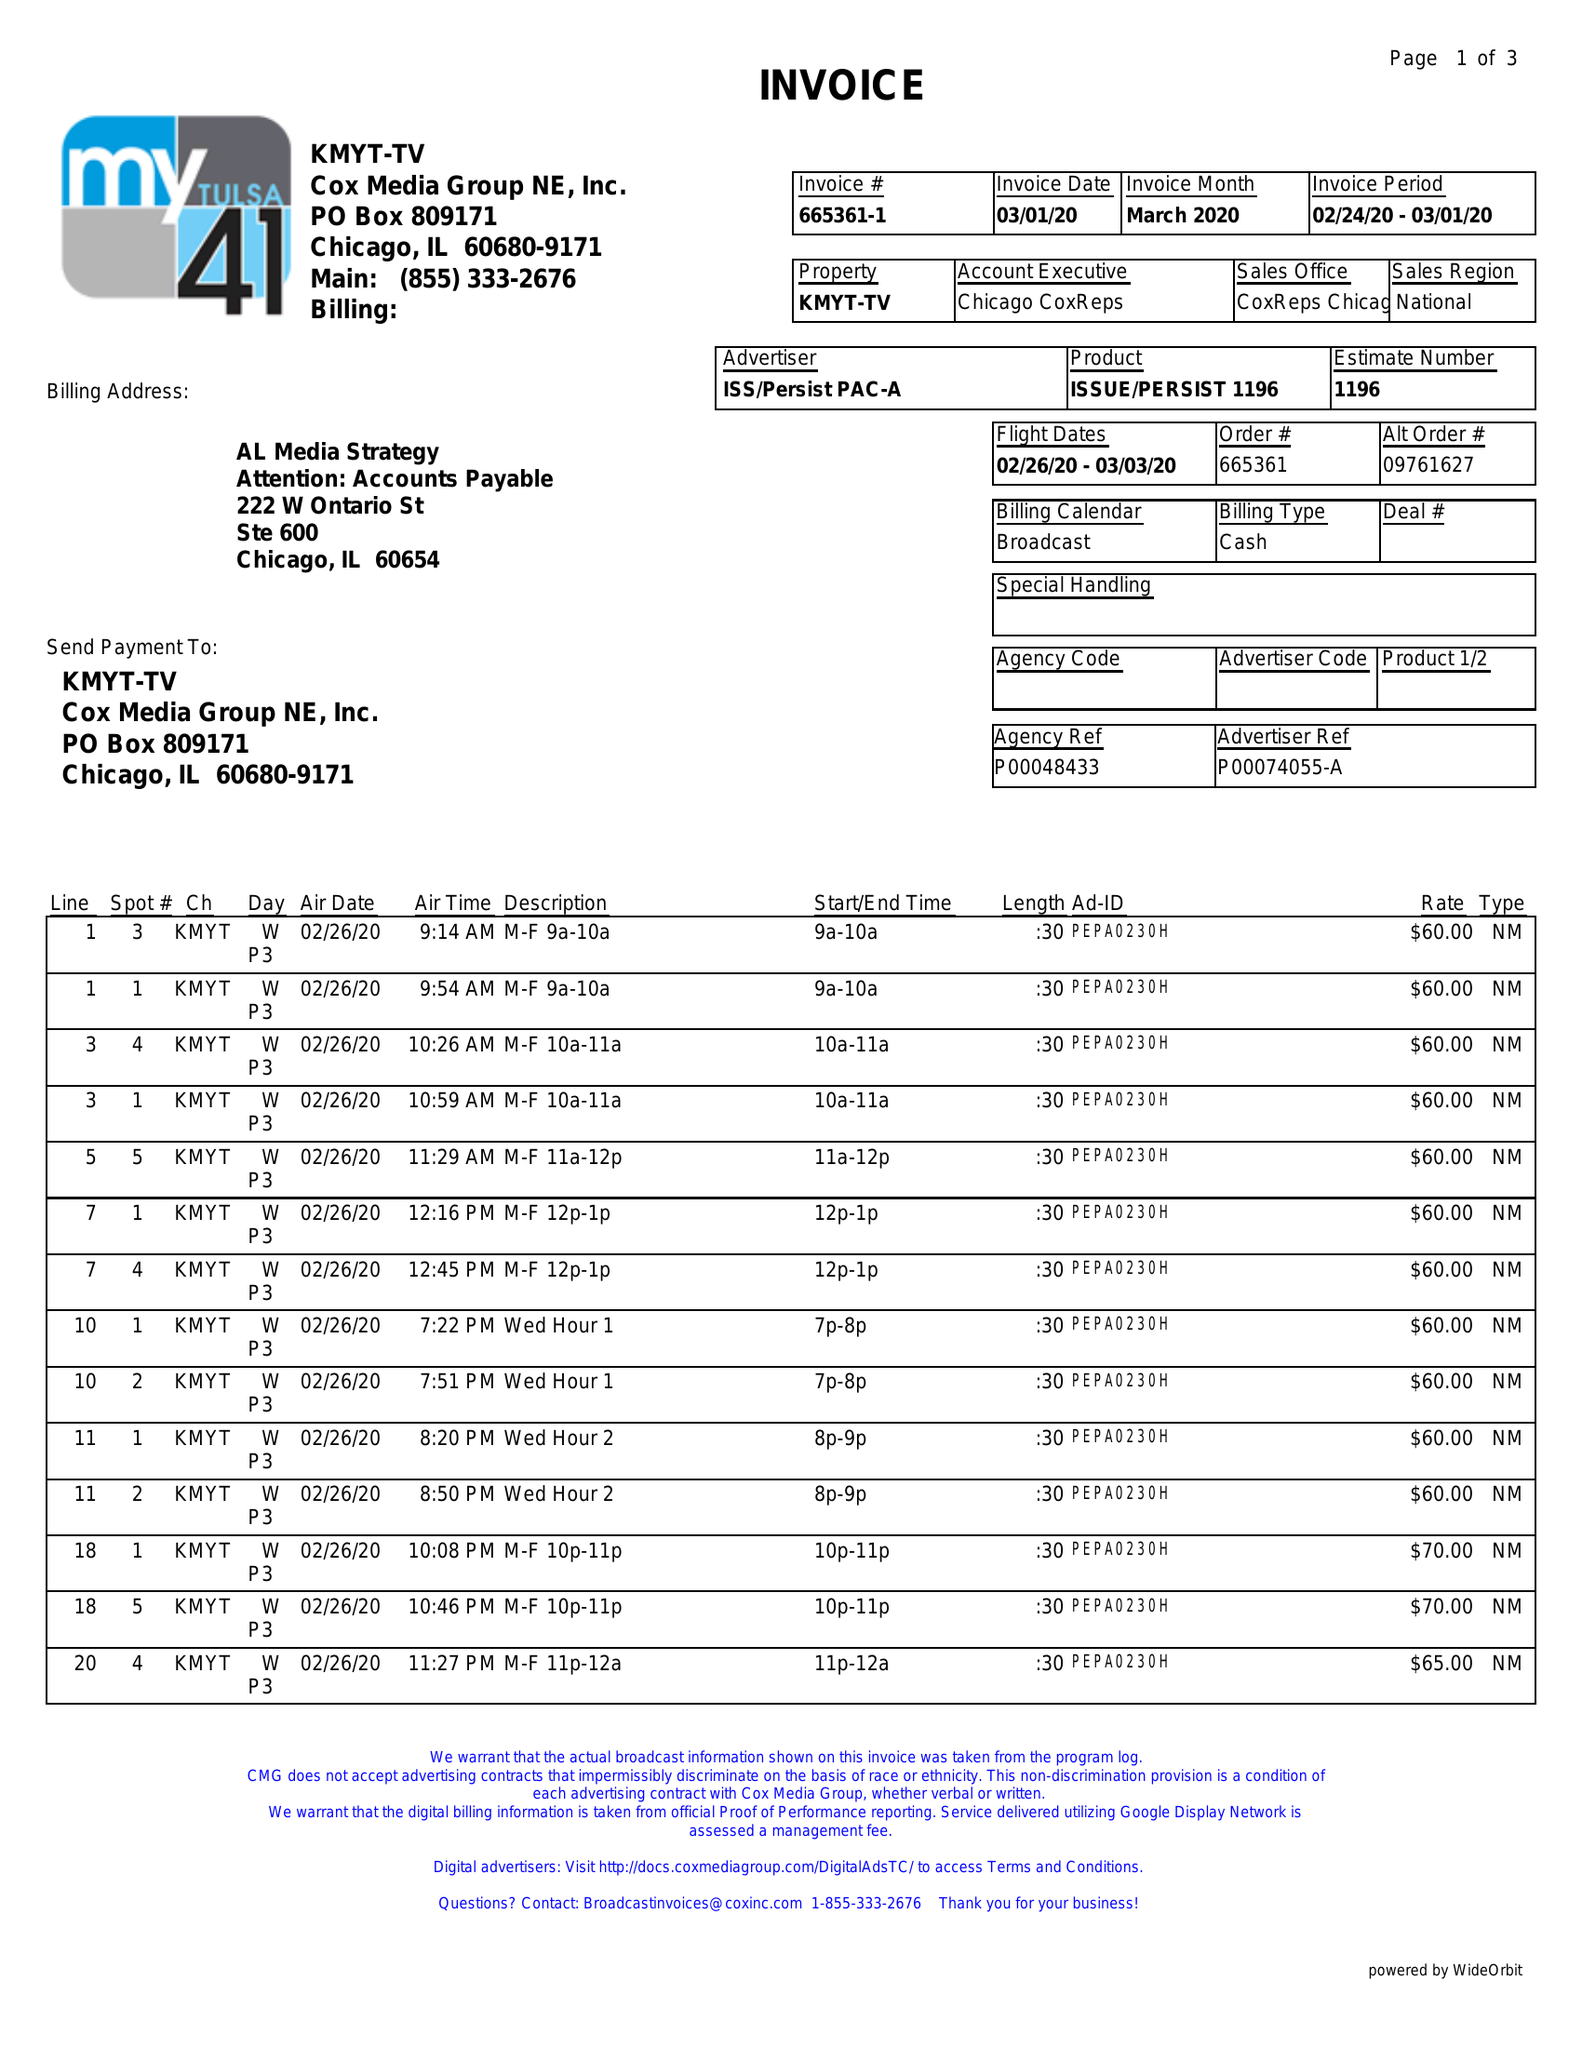What is the value for the advertiser?
Answer the question using a single word or phrase. ISS/PERSISTPAC-A 